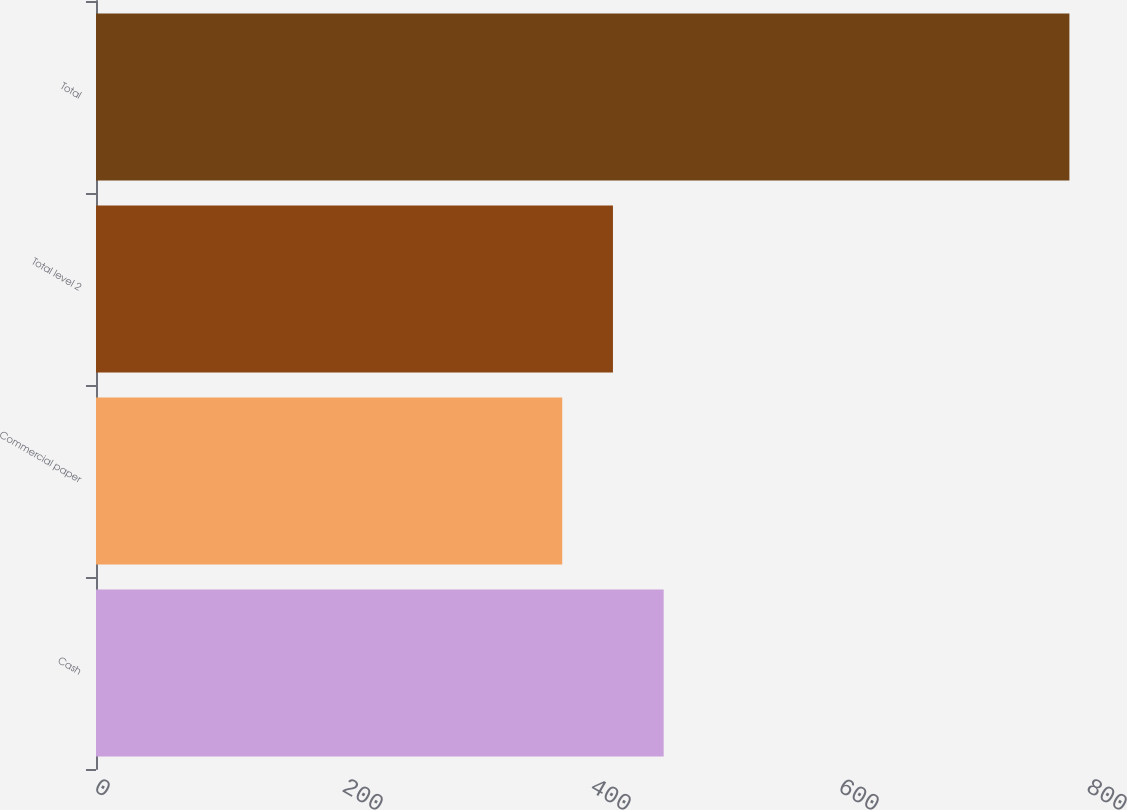<chart> <loc_0><loc_0><loc_500><loc_500><bar_chart><fcel>Cash<fcel>Commercial paper<fcel>Total level 2<fcel>Total<nl><fcel>457.8<fcel>376<fcel>416.9<fcel>785<nl></chart> 